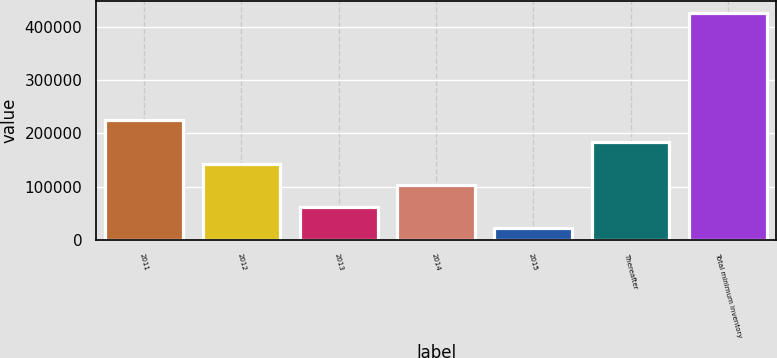Convert chart to OTSL. <chart><loc_0><loc_0><loc_500><loc_500><bar_chart><fcel>2011<fcel>2012<fcel>2013<fcel>2014<fcel>2015<fcel>Thereafter<fcel>Total minimum inventory<nl><fcel>224502<fcel>143256<fcel>62010.8<fcel>102634<fcel>21388<fcel>183879<fcel>427616<nl></chart> 